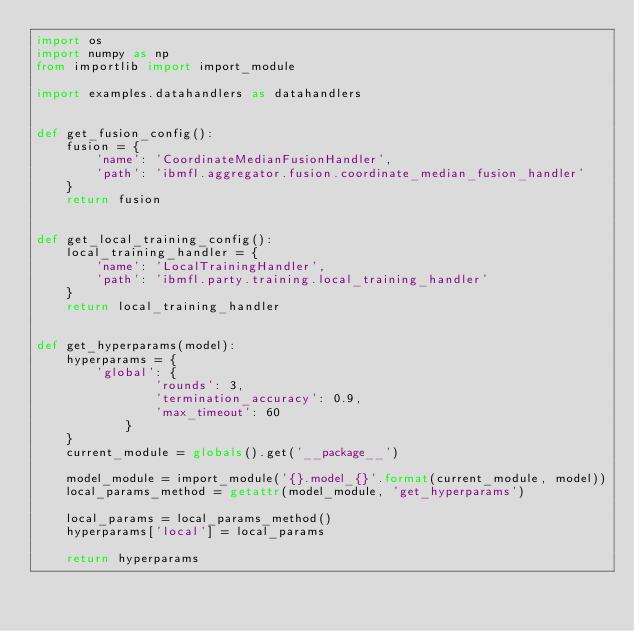<code> <loc_0><loc_0><loc_500><loc_500><_Python_>import os
import numpy as np
from importlib import import_module

import examples.datahandlers as datahandlers


def get_fusion_config():
    fusion = {
        'name': 'CoordinateMedianFusionHandler',
        'path': 'ibmfl.aggregator.fusion.coordinate_median_fusion_handler'
    }
    return fusion


def get_local_training_config():
    local_training_handler = {
        'name': 'LocalTrainingHandler',
        'path': 'ibmfl.party.training.local_training_handler'
    }
    return local_training_handler


def get_hyperparams(model):
    hyperparams = {
        'global': {
                'rounds': 3,
                'termination_accuracy': 0.9,
                'max_timeout': 60
            }
    }
    current_module = globals().get('__package__')
    
    model_module = import_module('{}.model_{}'.format(current_module, model))
    local_params_method = getattr(model_module, 'get_hyperparams')

    local_params = local_params_method()
    hyperparams['local'] = local_params
    
    return hyperparams

</code> 